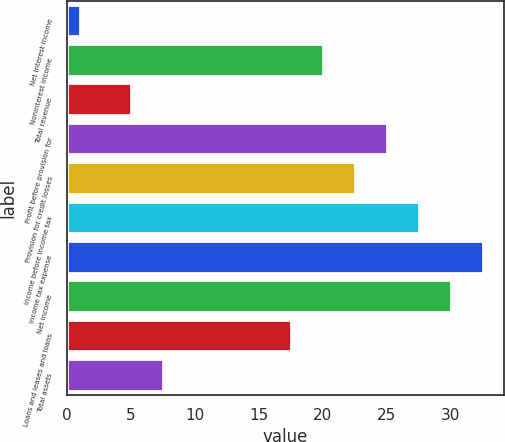<chart> <loc_0><loc_0><loc_500><loc_500><bar_chart><fcel>Net interest income<fcel>Noninterest income<fcel>Total revenue<fcel>Profit before provision for<fcel>Provision for credit losses<fcel>Income before income tax<fcel>Income tax expense<fcel>Net income<fcel>Loans and leases and loans<fcel>Total assets<nl><fcel>1<fcel>20<fcel>5<fcel>25<fcel>22.5<fcel>27.5<fcel>32.5<fcel>30<fcel>17.5<fcel>7.5<nl></chart> 